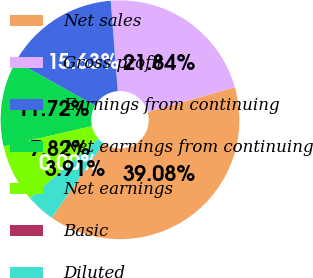Convert chart to OTSL. <chart><loc_0><loc_0><loc_500><loc_500><pie_chart><fcel>Net sales<fcel>Gross profit<fcel>Earnings from continuing<fcel>Net earnings from continuing<fcel>Net earnings<fcel>Basic<fcel>Diluted<nl><fcel>39.08%<fcel>21.84%<fcel>15.63%<fcel>11.72%<fcel>7.82%<fcel>0.0%<fcel>3.91%<nl></chart> 